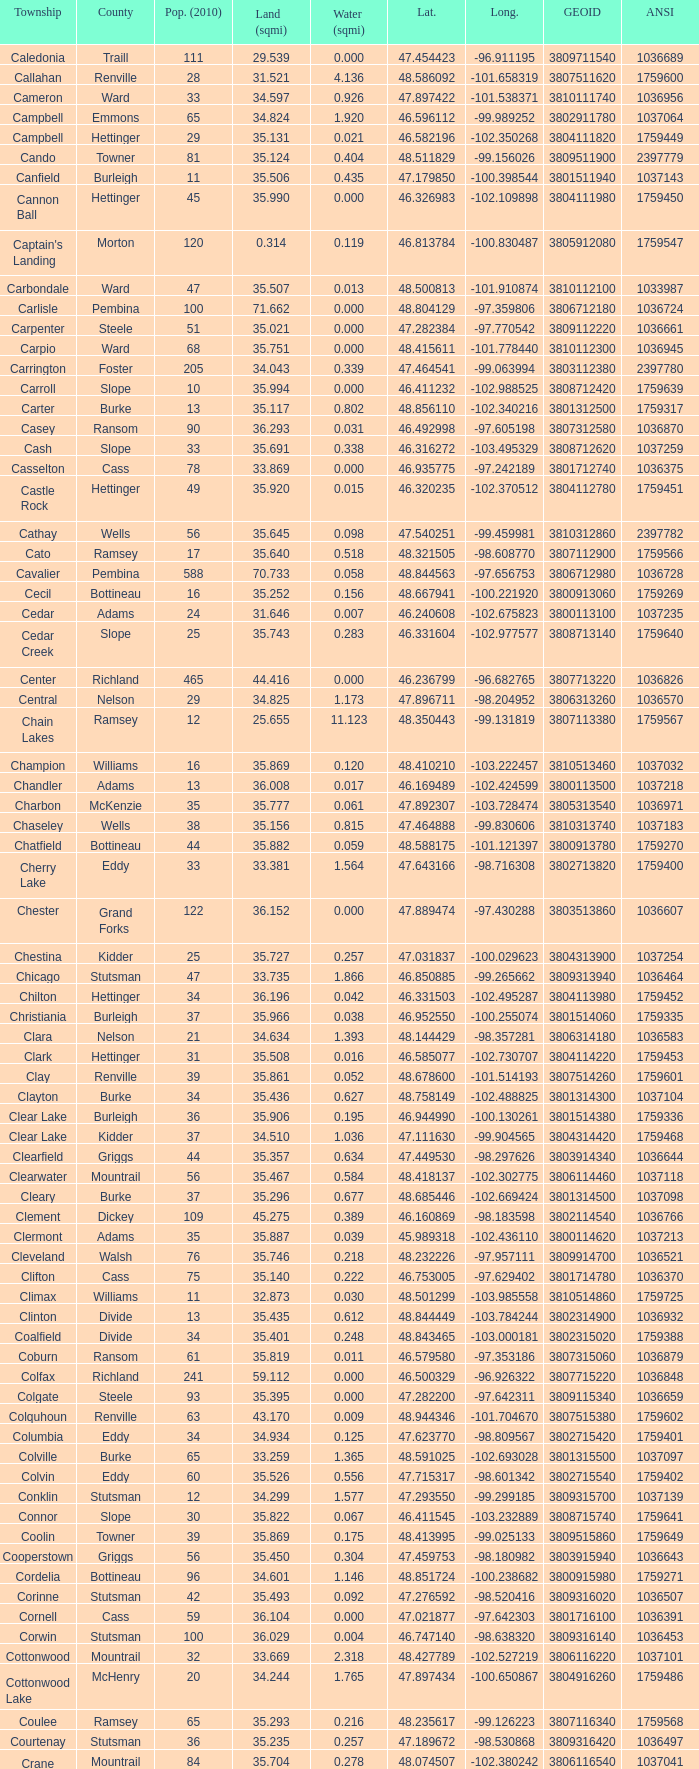What was the latitude of the Clearwater townsship? 48.418137. 